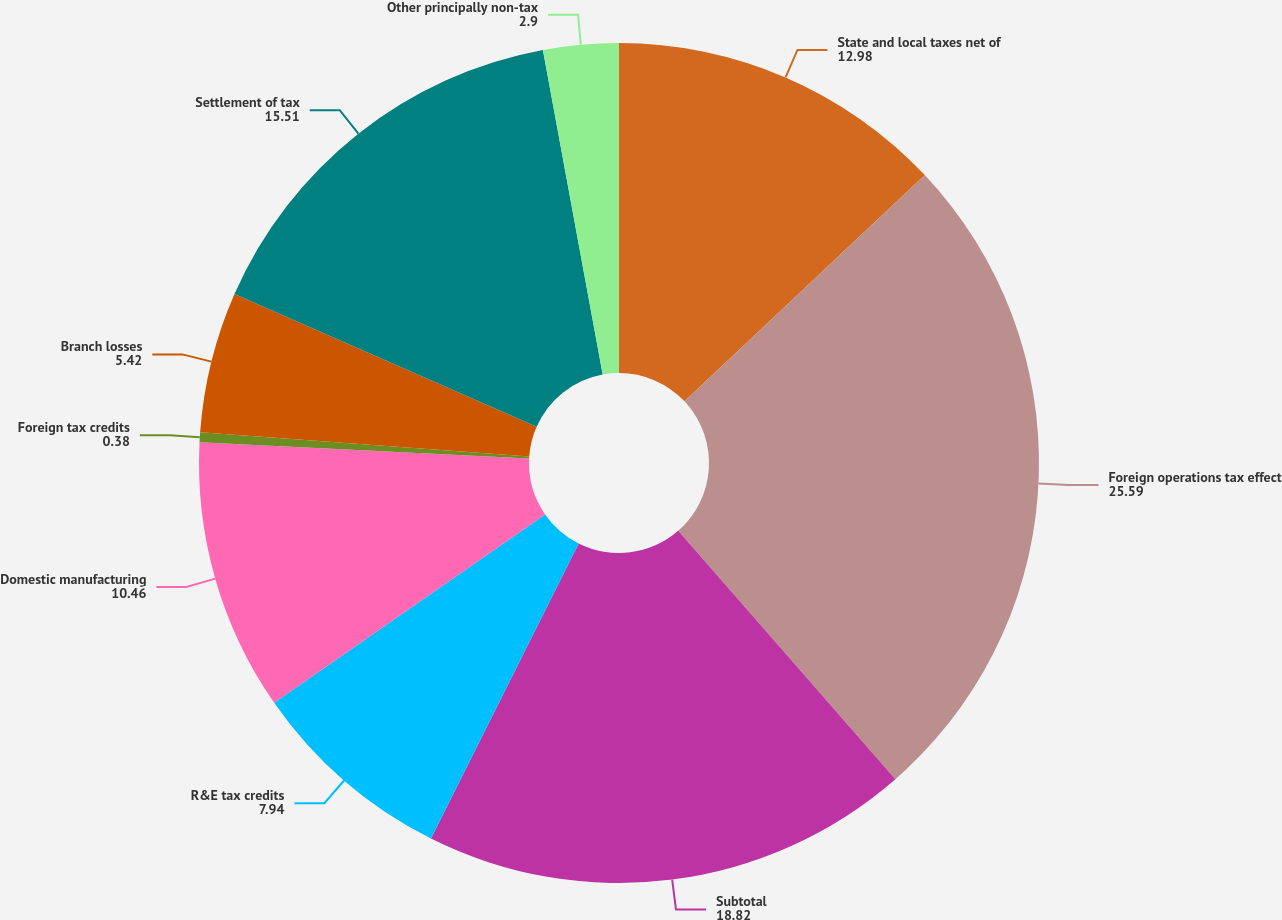Convert chart to OTSL. <chart><loc_0><loc_0><loc_500><loc_500><pie_chart><fcel>State and local taxes net of<fcel>Foreign operations tax effect<fcel>Subtotal<fcel>R&E tax credits<fcel>Domestic manufacturing<fcel>Foreign tax credits<fcel>Branch losses<fcel>Settlement of tax<fcel>Other principally non-tax<nl><fcel>12.98%<fcel>25.59%<fcel>18.82%<fcel>7.94%<fcel>10.46%<fcel>0.38%<fcel>5.42%<fcel>15.51%<fcel>2.9%<nl></chart> 